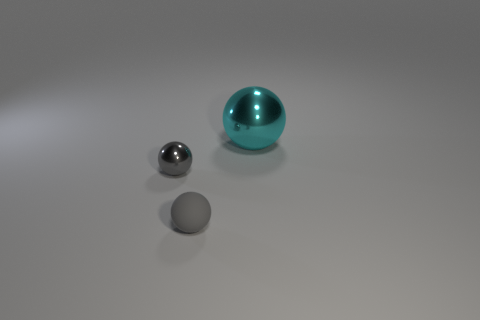Are there any other things that have the same size as the cyan shiny ball?
Ensure brevity in your answer.  No. Is the size of the thing left of the gray rubber sphere the same as the small gray matte object?
Your answer should be very brief. Yes. What number of red objects are either big balls or large metallic cylinders?
Give a very brief answer. 0. What is the tiny ball that is to the right of the small metallic object made of?
Ensure brevity in your answer.  Rubber. There is a metal sphere left of the cyan metallic thing; what number of rubber spheres are to the right of it?
Keep it short and to the point. 1. How many other shiny objects have the same shape as the big cyan object?
Provide a succinct answer. 1. How many big shiny things are there?
Ensure brevity in your answer.  1. What is the color of the shiny sphere that is left of the big shiny object?
Your response must be concise. Gray. There is a metal object on the left side of the metal sphere that is on the right side of the tiny gray matte ball; what is its color?
Offer a terse response. Gray. The other sphere that is the same size as the gray metal ball is what color?
Give a very brief answer. Gray. 